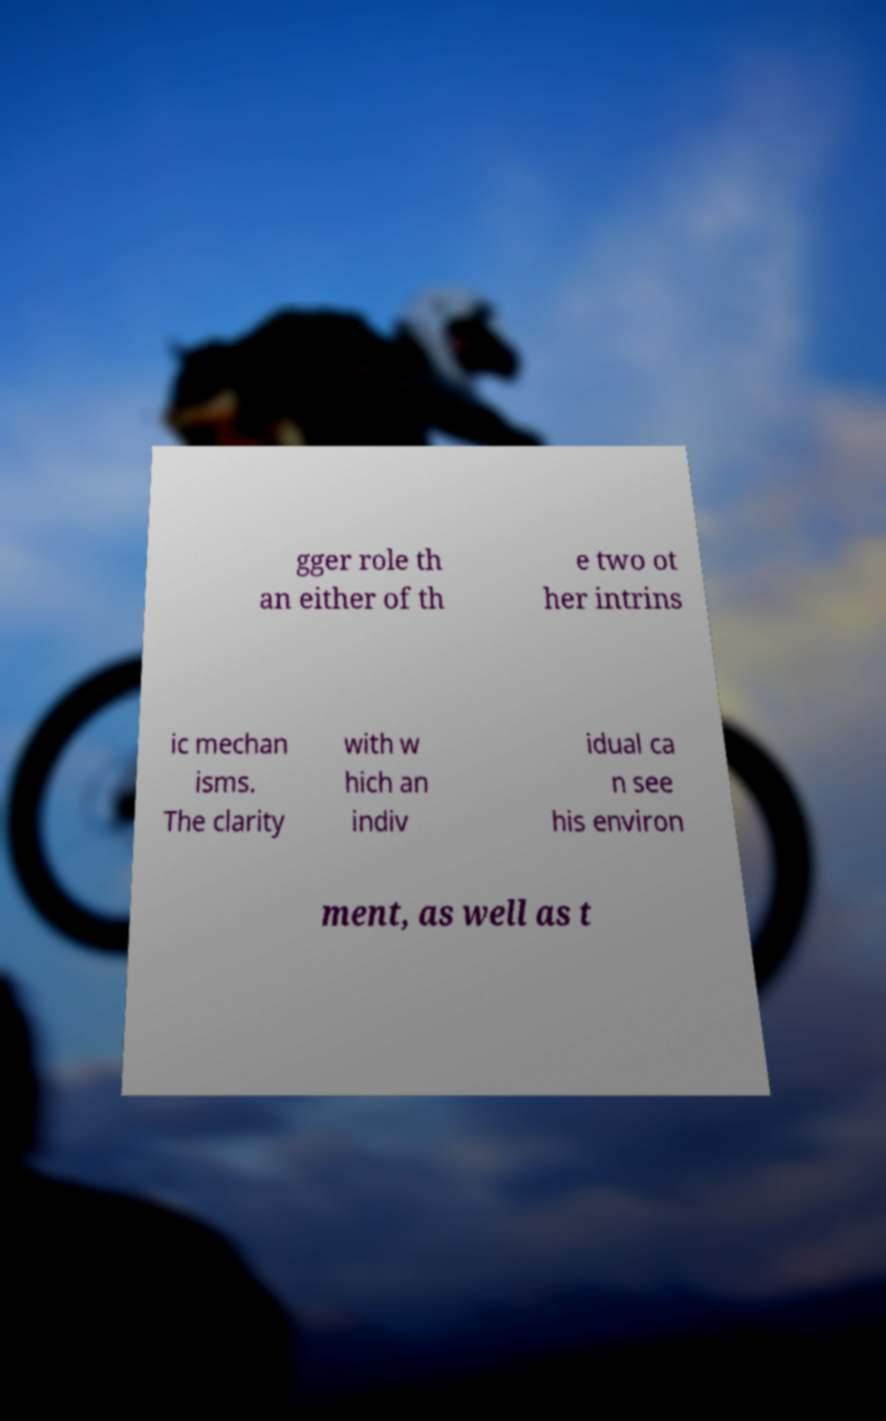Could you extract and type out the text from this image? gger role th an either of th e two ot her intrins ic mechan isms. The clarity with w hich an indiv idual ca n see his environ ment, as well as t 